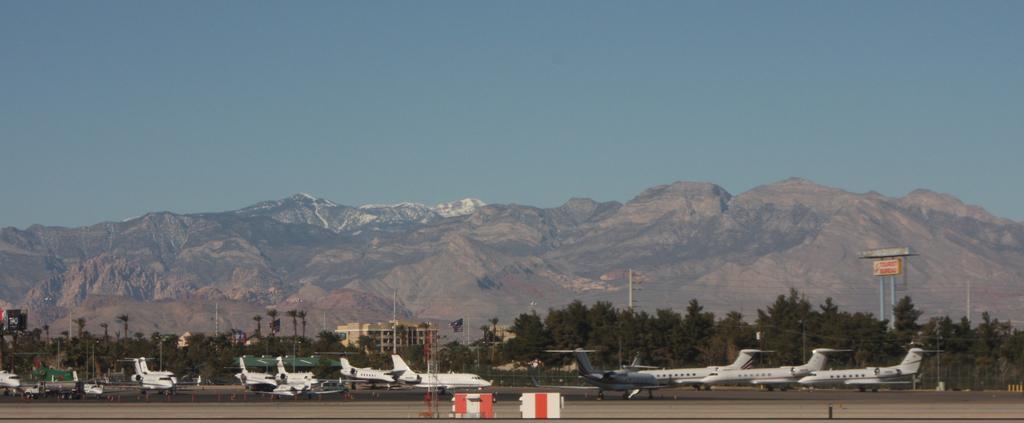Can you describe this image briefly? We can see airplanes on the road, barricades and pole. In the background we can see trees, buildings, poles, board on poles, mountain and sky in blue color. 